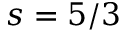Convert formula to latex. <formula><loc_0><loc_0><loc_500><loc_500>s = 5 / 3</formula> 